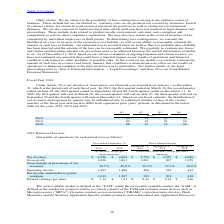According to Stmicroelectronics's financial document, What is the full form of TAM? The total available market is defined as the “TAM”. The document states: "The total available market is defined as the “TAM”, while the serviceable available market, the “SAM”, is defined as the market for products sold by u..." Also, What is the full form of SAM? the serviceable available market. The document states: "l available market is defined as the “TAM”, while the serviceable available market, the “SAM”, is defined as the market for products sold by us (which..." Also, What is defined as SAM? the serviceable available market, the “SAM”, is defined as the market for products sold by us (which consists of the TAM and excludes major devices such as Microprocessors (“MPUs”), Dynamic random-access memories (“DRAMs”), optoelectronics devices, Flash Memories and the Wireless Application Specific market products such as Baseband and Application Processor).. The document states: "al available market is defined as the “TAM”, while the serviceable available market, the “SAM”, is defined as the market for products sold by us (whic..." Also, can you calculate: What are the average net revenues for year ended December 31? To answer this question, I need to perform calculations using the financial data. The calculation is: (9,556+9,664) / 2, which equals 9610 (in millions). This is based on the information: "Net revenues $ 9,556 $ 9,664 $ 2,754 $ 2,553 $ 2,648 Net revenues $ 9,556 $ 9,664 $ 2,754 $ 2,553 $ 2,648..." The key data points involved are: 9,556, 9,664. Also, can you calculate: What is the increase/ (decrease) in net revenues for year ended December 31, from 2018 to 2019? Based on the calculation: 9,556-9,664, the result is -108 (in millions). This is based on the information: "Net revenues $ 9,556 $ 9,664 $ 2,754 $ 2,553 $ 2,648 Net revenues $ 9,556 $ 9,664 $ 2,754 $ 2,553 $ 2,648..." The key data points involved are: 9,556, 9,664. Also, can you calculate: What is the increase/ (decrease) in gross profit for year ended December 31, from 2018 to 2019? Based on the calculation: 3,696-3,861, the result is -165 (in millions). This is based on the information: "Gross profit 3,696 3,861 1,081 967 1,059 Gross profit 3,696 3,861 1,081 967 1,059..." The key data points involved are: 3,696, 3,861. 